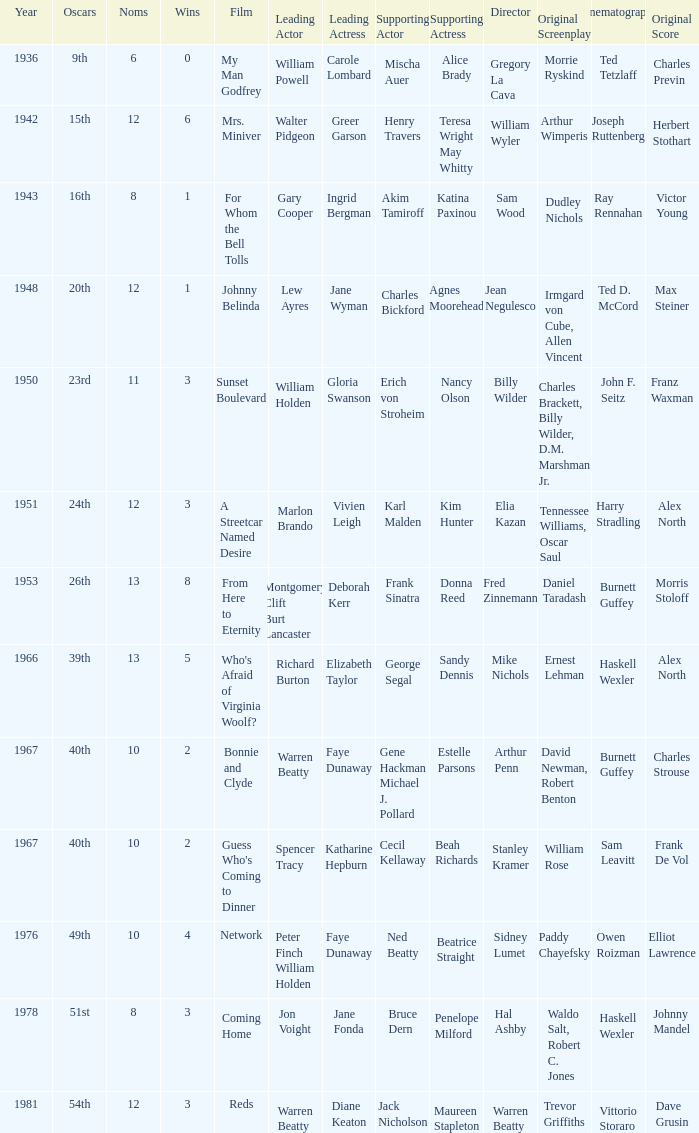Who was the supporting actress in a film with Diane Keaton as the leading actress? Maureen Stapleton. Parse the table in full. {'header': ['Year', 'Oscars', 'Noms', 'Wins', 'Film', 'Leading Actor', 'Leading Actress', 'Supporting Actor', 'Supporting Actress', 'Director', 'Original Screenplay', 'Cinematography', 'Original Score'], 'rows': [['1936', '9th', '6', '0', 'My Man Godfrey', 'William Powell', 'Carole Lombard', 'Mischa Auer', 'Alice Brady', 'Gregory La Cava', 'Morrie Ryskind', 'Ted Tetzlaff', 'Charles Previn'], ['1942', '15th', '12', '6', 'Mrs. Miniver', 'Walter Pidgeon', 'Greer Garson', 'Henry Travers', 'Teresa Wright May Whitty', 'William Wyler', 'Arthur Wimperis', 'Joseph Ruttenberg', 'Herbert Stothart'], ['1943', '16th', '8', '1', 'For Whom the Bell Tolls', 'Gary Cooper', 'Ingrid Bergman', 'Akim Tamiroff', 'Katina Paxinou', 'Sam Wood', 'Dudley Nichols', 'Ray Rennahan', 'Victor Young'], ['1948', '20th', '12', '1', 'Johnny Belinda', 'Lew Ayres', 'Jane Wyman', 'Charles Bickford', 'Agnes Moorehead', 'Jean Negulesco', 'Irmgard von Cube, Allen Vincent', 'Ted D. McCord', 'Max Steiner'], ['1950', '23rd', '11', '3', 'Sunset Boulevard', 'William Holden', 'Gloria Swanson', 'Erich von Stroheim', 'Nancy Olson', 'Billy Wilder', 'Charles Brackett, Billy Wilder, D.M. Marshman Jr.', 'John F. Seitz', 'Franz Waxman'], ['1951', '24th', '12', '3', 'A Streetcar Named Desire', 'Marlon Brando', 'Vivien Leigh', 'Karl Malden', 'Kim Hunter', 'Elia Kazan', 'Tennessee Williams, Oscar Saul', 'Harry Stradling', 'Alex North'], ['1953', '26th', '13', '8', 'From Here to Eternity', 'Montgomery Clift Burt Lancaster', 'Deborah Kerr', 'Frank Sinatra', 'Donna Reed', 'Fred Zinnemann', 'Daniel Taradash', 'Burnett Guffey', 'Morris Stoloff'], ['1966', '39th', '13', '5', "Who's Afraid of Virginia Woolf?", 'Richard Burton', 'Elizabeth Taylor', 'George Segal', 'Sandy Dennis', 'Mike Nichols', 'Ernest Lehman', 'Haskell Wexler', 'Alex North'], ['1967', '40th', '10', '2', 'Bonnie and Clyde', 'Warren Beatty', 'Faye Dunaway', 'Gene Hackman Michael J. Pollard', 'Estelle Parsons', 'Arthur Penn', 'David Newman, Robert Benton', 'Burnett Guffey', 'Charles Strouse'], ['1967', '40th', '10', '2', "Guess Who's Coming to Dinner", 'Spencer Tracy', 'Katharine Hepburn', 'Cecil Kellaway', 'Beah Richards', 'Stanley Kramer', 'William Rose', 'Sam Leavitt', 'Frank De Vol'], ['1976', '49th', '10', '4', 'Network', 'Peter Finch William Holden', 'Faye Dunaway', 'Ned Beatty', 'Beatrice Straight', 'Sidney Lumet', 'Paddy Chayefsky', 'Owen Roizman', 'Elliot Lawrence'], ['1978', '51st', '8', '3', 'Coming Home', 'Jon Voight', 'Jane Fonda', 'Bruce Dern', 'Penelope Milford', 'Hal Ashby', 'Waldo Salt, Robert C. Jones', 'Haskell Wexler', 'Johnny Mandel'], ['1981', '54th', '12', '3', 'Reds', 'Warren Beatty', 'Diane Keaton', 'Jack Nicholson', 'Maureen Stapleton', 'Warren Beatty', 'Trevor Griffiths', 'Vittorio Storaro', 'Dave Grusin']]} 